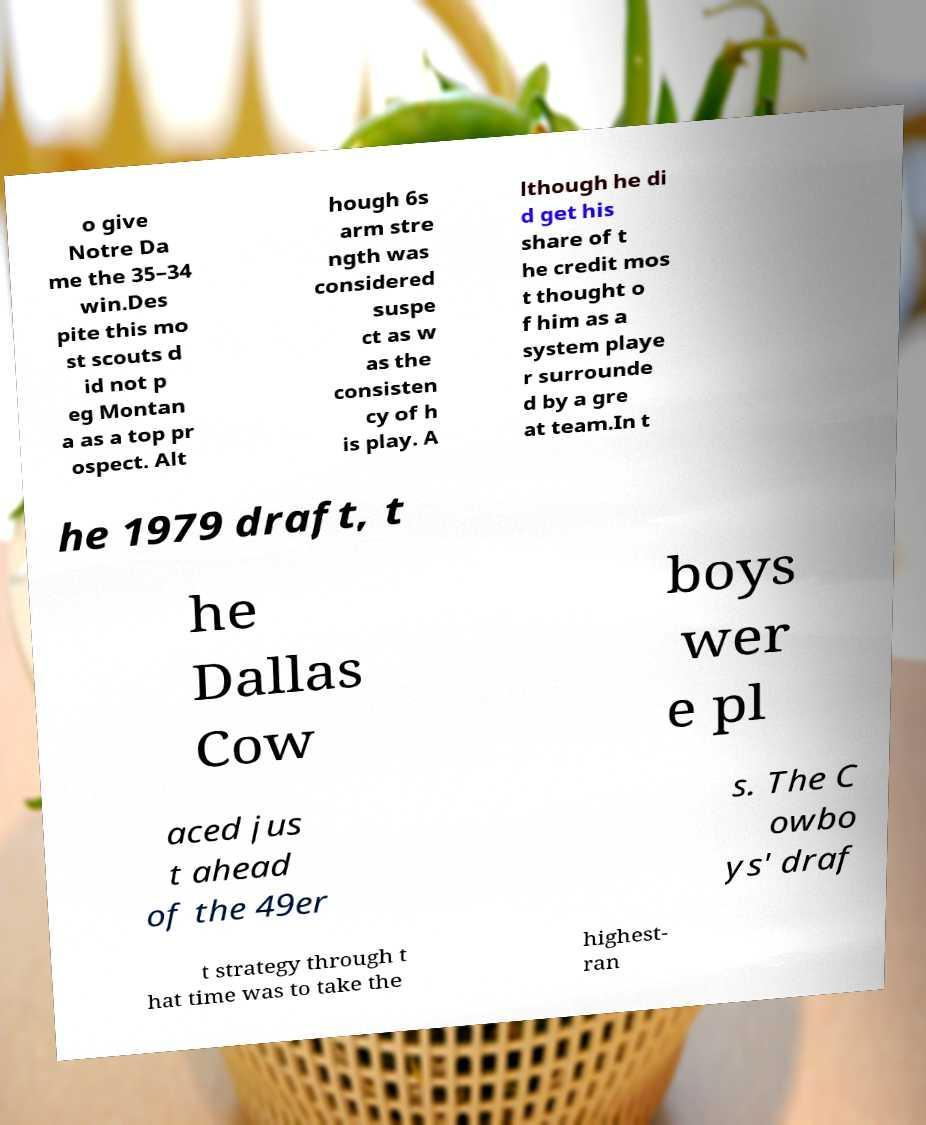Please identify and transcribe the text found in this image. o give Notre Da me the 35–34 win.Des pite this mo st scouts d id not p eg Montan a as a top pr ospect. Alt hough 6s arm stre ngth was considered suspe ct as w as the consisten cy of h is play. A lthough he di d get his share of t he credit mos t thought o f him as a system playe r surrounde d by a gre at team.In t he 1979 draft, t he Dallas Cow boys wer e pl aced jus t ahead of the 49er s. The C owbo ys' draf t strategy through t hat time was to take the highest- ran 